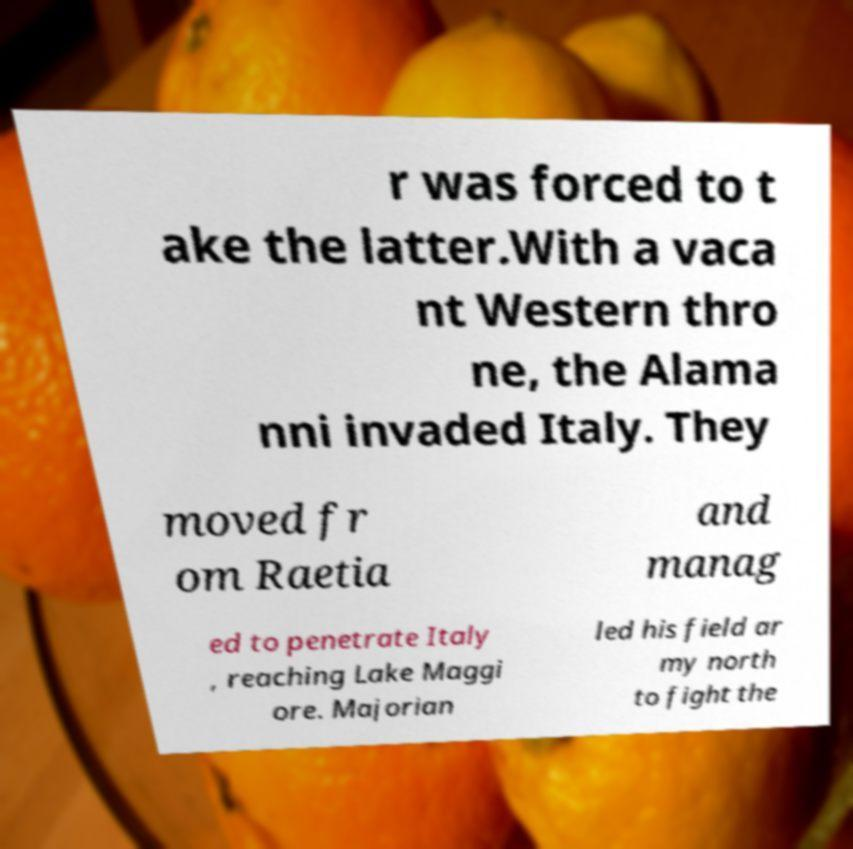What messages or text are displayed in this image? I need them in a readable, typed format. r was forced to t ake the latter.With a vaca nt Western thro ne, the Alama nni invaded Italy. They moved fr om Raetia and manag ed to penetrate Italy , reaching Lake Maggi ore. Majorian led his field ar my north to fight the 